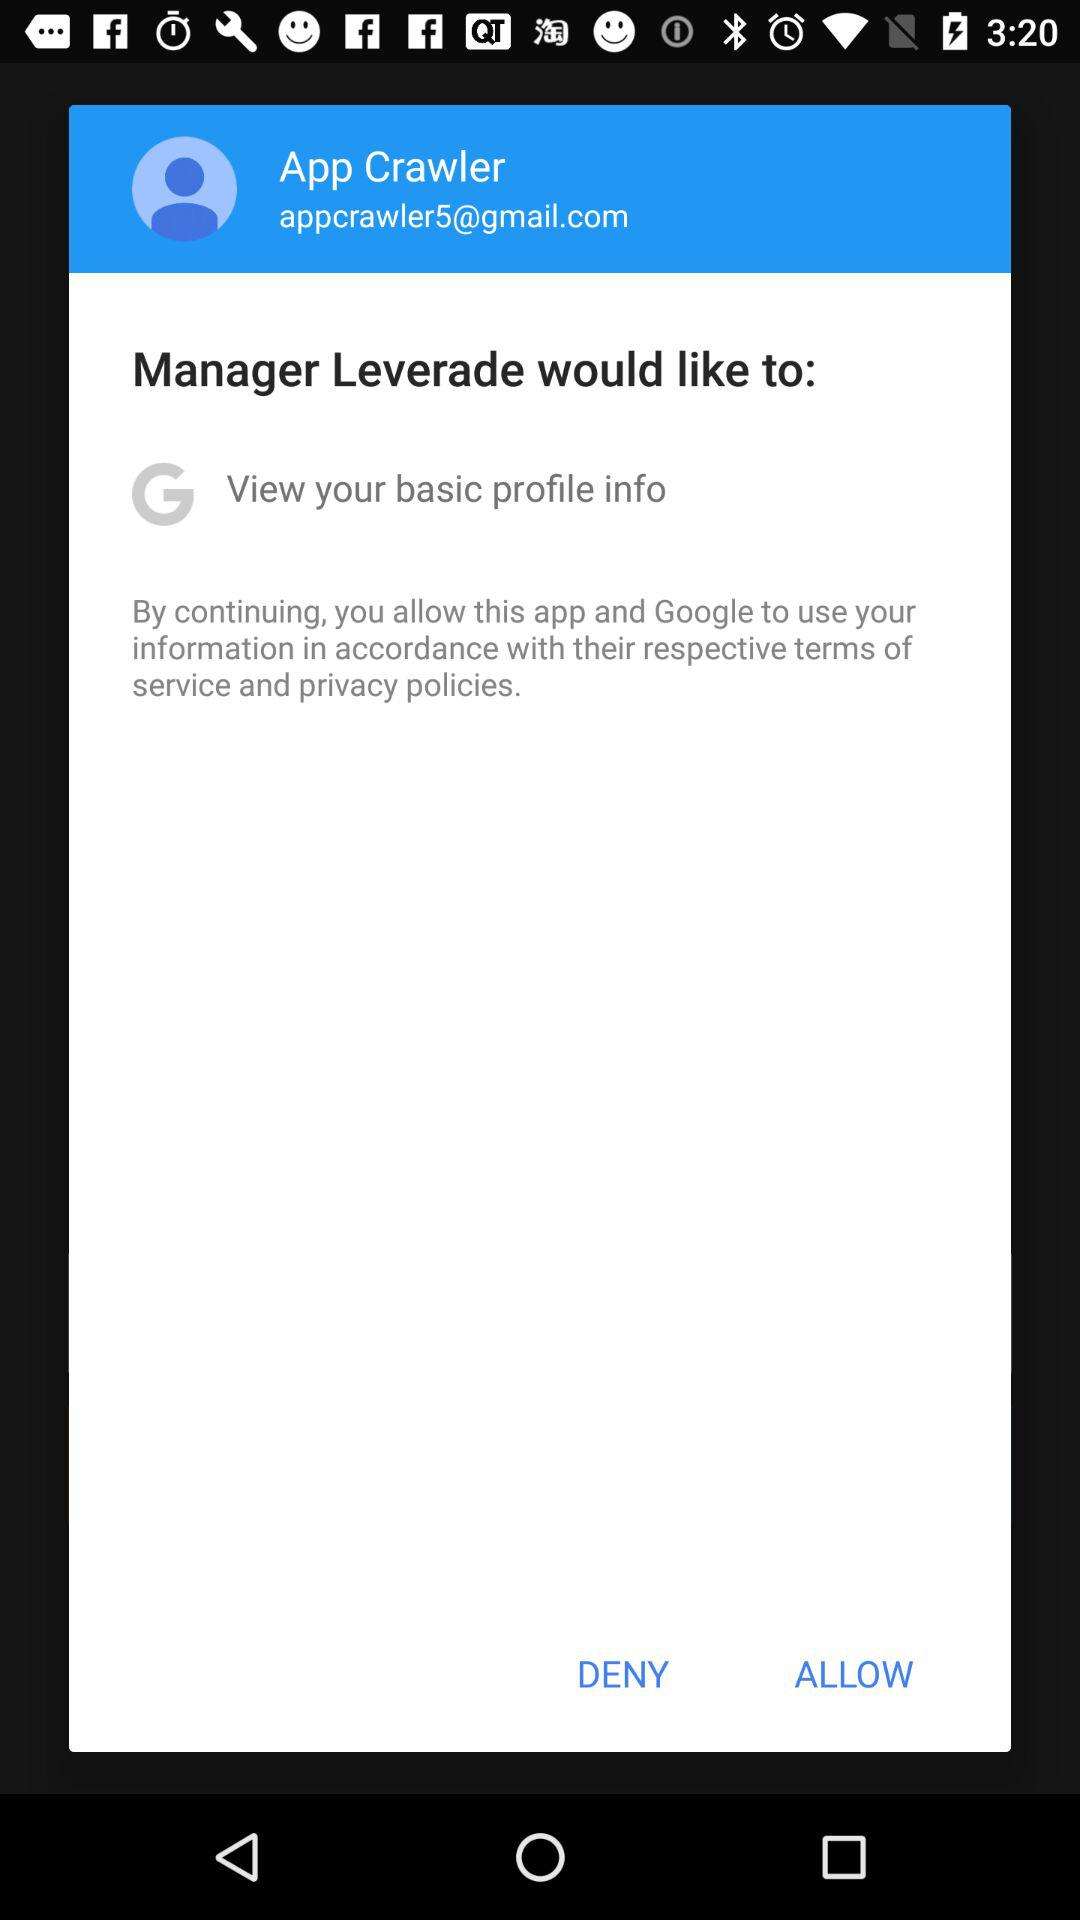Are the terms of service and privacy policy accepted or not?
When the provided information is insufficient, respond with <no answer>. <no answer> 